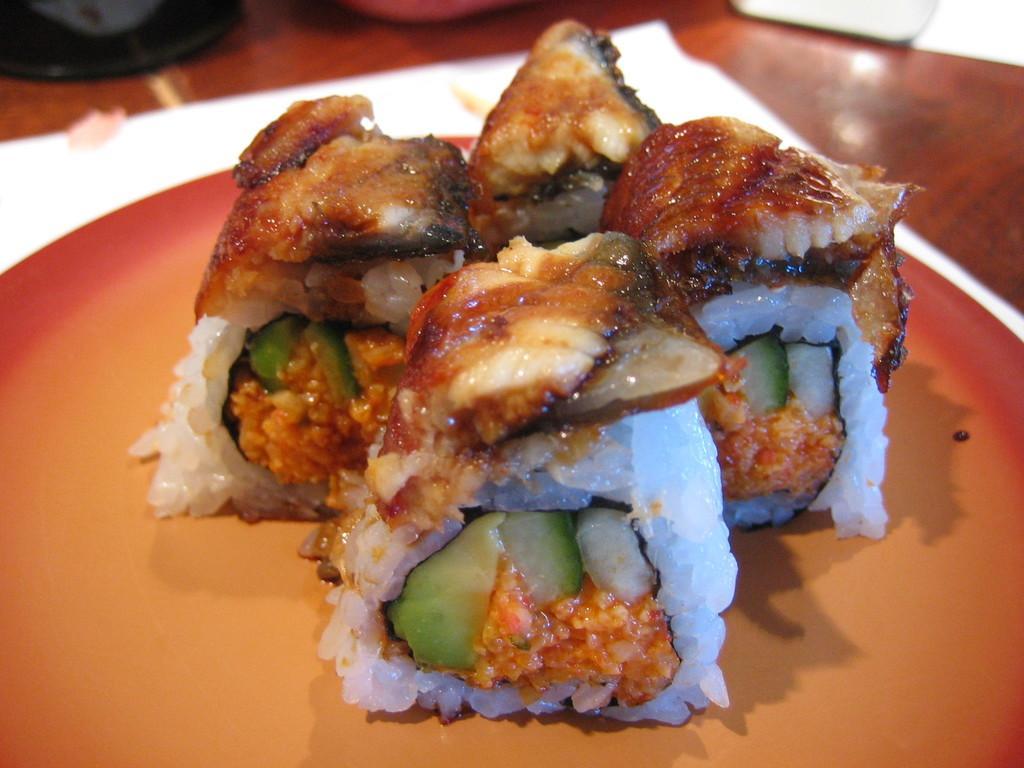How would you summarize this image in a sentence or two? In the picture we can see a table on it we can see a plate with some sweets in it. 